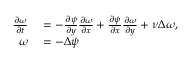Convert formula to latex. <formula><loc_0><loc_0><loc_500><loc_500>\begin{array} { r l } { \frac { \partial \omega } { \partial t } } & = - \frac { \partial \psi } { \partial y } \frac { \partial \omega } { \partial x } + \frac { \partial \psi } { \partial x } \frac { \partial \omega } { \partial y } + \nu \Delta \omega , } \\ { \omega } & = - \Delta \psi } \end{array}</formula> 